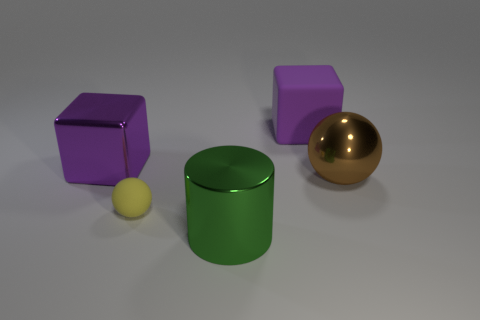What number of other matte spheres have the same size as the brown sphere?
Ensure brevity in your answer.  0. Is the number of big purple rubber things in front of the tiny object the same as the number of large purple cubes in front of the big shiny block?
Offer a very short reply. Yes. Is the big brown thing made of the same material as the big cylinder?
Ensure brevity in your answer.  Yes. Are there any metallic cubes to the right of the sphere that is on the left side of the brown metal sphere?
Make the answer very short. No. Are there any big brown matte things that have the same shape as the large green metal object?
Offer a very short reply. No. Do the big sphere and the big cylinder have the same color?
Your answer should be very brief. No. There is a large cube that is on the left side of the big block that is right of the cylinder; what is it made of?
Keep it short and to the point. Metal. The brown sphere is what size?
Your answer should be very brief. Large. There is a purple cube that is the same material as the brown object; what is its size?
Make the answer very short. Large. Do the purple cube to the right of the metal cube and the brown shiny ball have the same size?
Make the answer very short. Yes. 